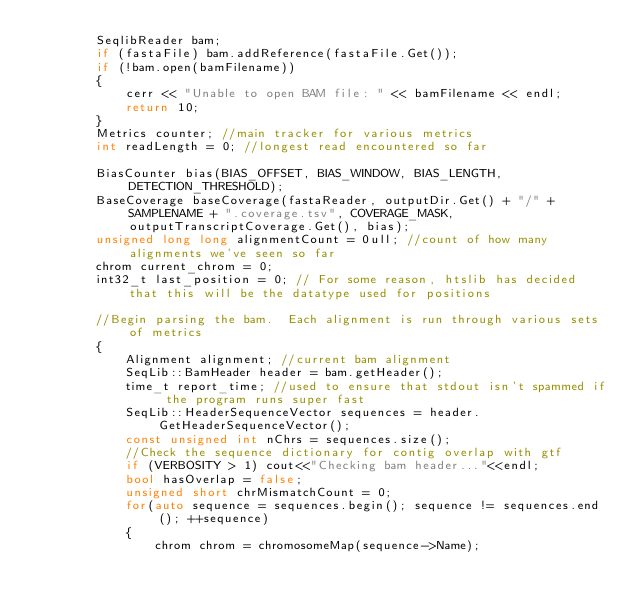Convert code to text. <code><loc_0><loc_0><loc_500><loc_500><_C++_>        SeqlibReader bam;
        if (fastaFile) bam.addReference(fastaFile.Get());
        if (!bam.open(bamFilename))
        {
            cerr << "Unable to open BAM file: " << bamFilename << endl;
            return 10;
        }
        Metrics counter; //main tracker for various metrics
        int readLength = 0; //longest read encountered so far

        BiasCounter bias(BIAS_OFFSET, BIAS_WINDOW, BIAS_LENGTH, DETECTION_THRESHOLD);
        BaseCoverage baseCoverage(fastaReader, outputDir.Get() + "/" + SAMPLENAME + ".coverage.tsv", COVERAGE_MASK, outputTranscriptCoverage.Get(), bias);
        unsigned long long alignmentCount = 0ull; //count of how many alignments we've seen so far
        chrom current_chrom = 0;
        int32_t last_position = 0; // For some reason, htslib has decided that this will be the datatype used for positions

        //Begin parsing the bam.  Each alignment is run through various sets of metrics
        {
            Alignment alignment; //current bam alignment
            SeqLib::BamHeader header = bam.getHeader();
            time_t report_time; //used to ensure that stdout isn't spammed if the program runs super fast
            SeqLib::HeaderSequenceVector sequences = header.GetHeaderSequenceVector();
            const unsigned int nChrs = sequences.size();
            //Check the sequence dictionary for contig overlap with gtf
            if (VERBOSITY > 1) cout<<"Checking bam header..."<<endl;
            bool hasOverlap = false;
            unsigned short chrMismatchCount = 0;
            for(auto sequence = sequences.begin(); sequence != sequences.end(); ++sequence)
            {
                chrom chrom = chromosomeMap(sequence->Name);</code> 